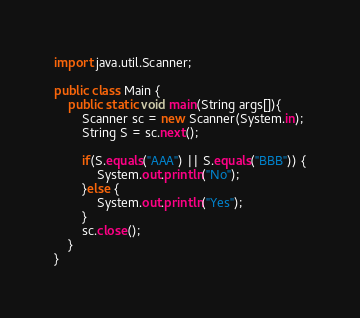<code> <loc_0><loc_0><loc_500><loc_500><_Java_>import java.util.Scanner;

public class Main {
	public static void main(String args[]){
		Scanner sc = new Scanner(System.in);
		String S = sc.next();

		if(S.equals("AAA") || S.equals("BBB")) {
			System.out.println("No");
		}else {
			System.out.println("Yes");
		}	
		sc.close();
	}
}
</code> 